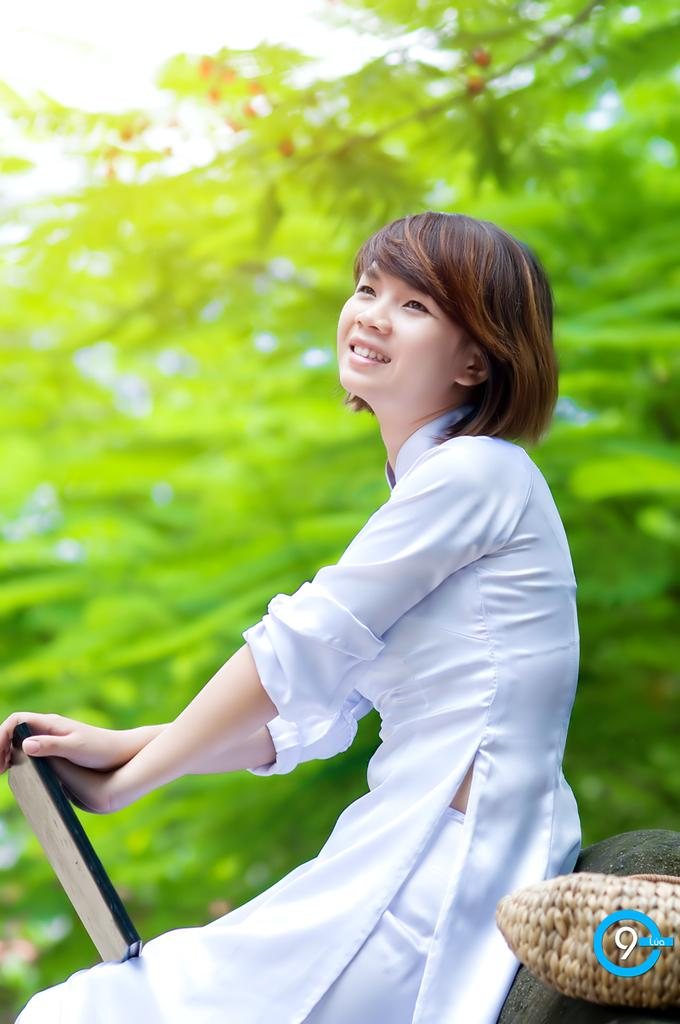Who is the main subject in the image? There is a woman in the center of the image. What is the woman doing in the image? The woman is sitting. What is the woman holding in the image? The woman is holding something. What is located beside the woman in the image? There is a basket beside the woman. What can be seen in the background of the image? There are trees in the background of the image. What type of neck accessory is the woman wearing in the image? There is no information about the woman's neck accessory in the image, as the focus is on her sitting position, what she is holding, and the presence of the basket and trees in the background. --- Facts: 1. There is a car in the image. 2. The car is red. 3. The car has four wheels. 4. There are people in the car. 5. The car is parked on the street. Absurd Topics: ocean, bird, mountain Conversation: What is the main subject in the image? There is a car in the image. What color is the car? The car is red. How many wheels does the car have? The car has four wheels. Who is inside the car? There are people in the car. Where is the car located in the image? The car is parked on the street. Reasoning: Let's think step by step in order to produce the conversation. We start by identifying the main subject in the image, which is the car. Then, we describe its color and the number of wheels it has. Next, we mention the presence of people inside the car. Finally, we describe the car's location, which is parked on the street. Each question is designed to elicit a specific detail about the image that is known from the provided facts. Absurd Question/Answer: Can you see any mountains in the background of the image? There is no mention of mountains in the image; the focus is on the red car, its wheels, the people inside, and its location on the street. 